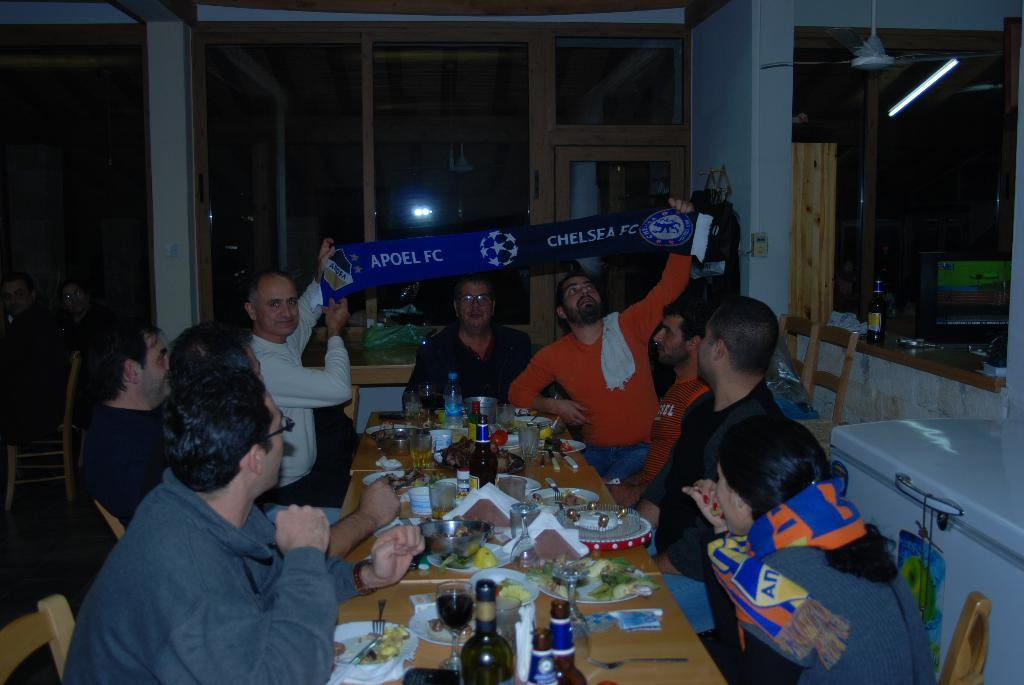How many people are in the image? There is a group of people in the image, but the exact number is not specified. What are the people in the image doing? The people are sitting in the image. What do the people have in their hands? The people are holding a banner in the image. What is located in front of the group? There is a table in front of the group. What can be seen on the table? There are wine bottles and food on the table. What type of skate is being used by the people in the image? There is no skate present in the image; the people are sitting and holding a banner. What songs are being sung by the people in the image? There is no indication of singing or any songs in the image. 